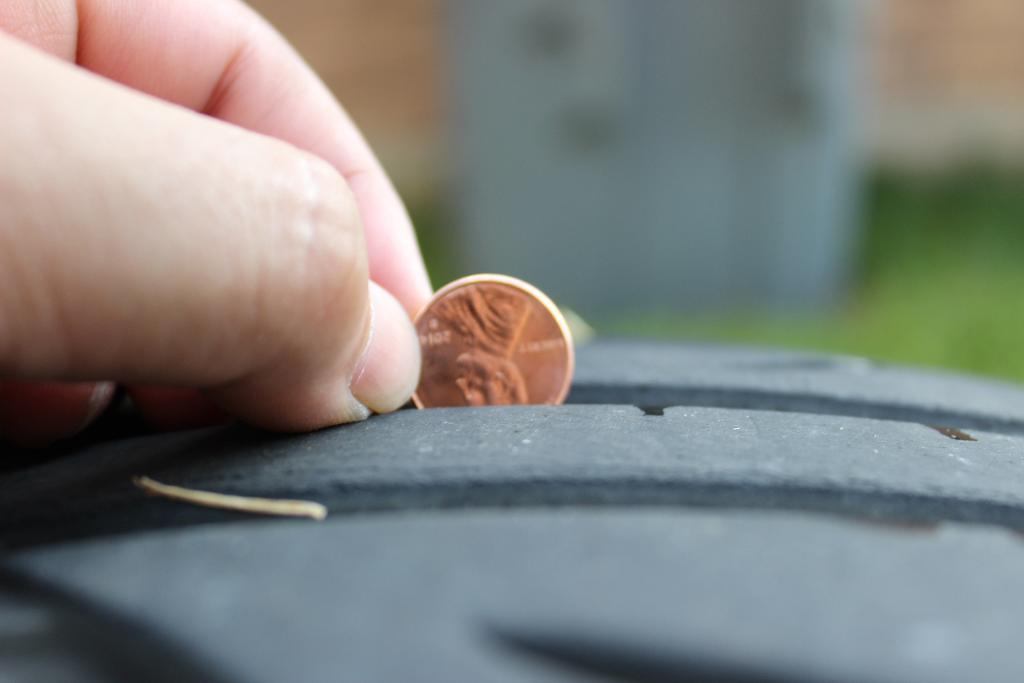What is the hand holding in the image? The hand is holding a coin in the image. What object is located at the bottom of the image? There is a box at the bottom of the image. Can you describe the background of the image? The background of the image is blurred. What type of corn is being sold at the price indicated on the box in the image? There is no corn or price mentioned in the image; it only features a hand holding a coin and a box at the bottom. 